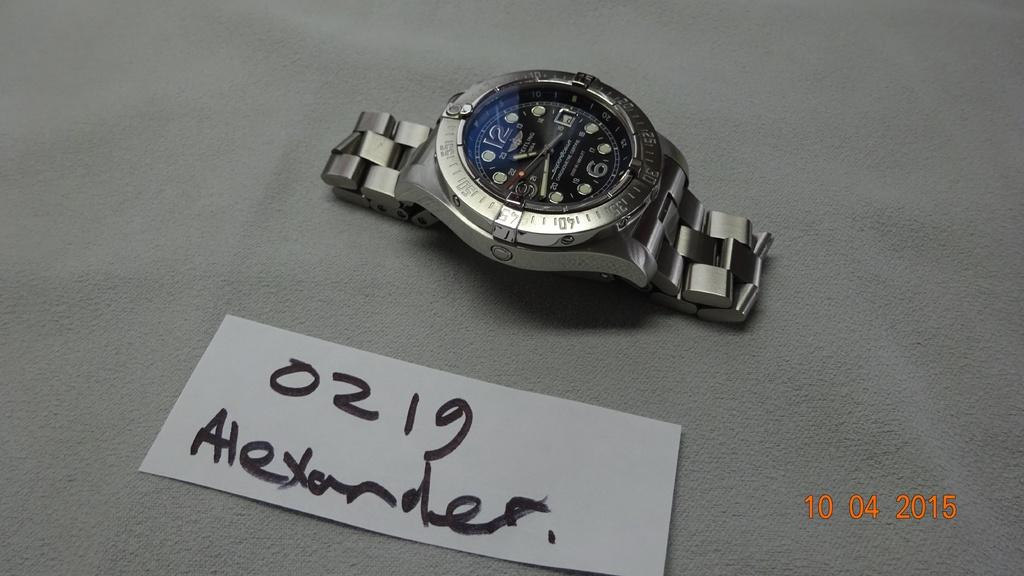<image>
Provide a brief description of the given image. A sign next to a silver watch reads 0219 Alexander 